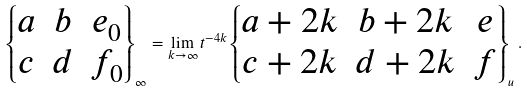<formula> <loc_0><loc_0><loc_500><loc_500>\left \{ \begin{matrix} a & b & e _ { 0 } \\ c & d & f _ { 0 } \end{matrix} \right \} _ { \infty } = \lim _ { k \rightarrow \infty } t ^ { - 4 k } \left \{ \begin{matrix} a + 2 k & b + 2 k & e \\ c + 2 k & d + 2 k & f \end{matrix} \right \} _ { u } .</formula> 